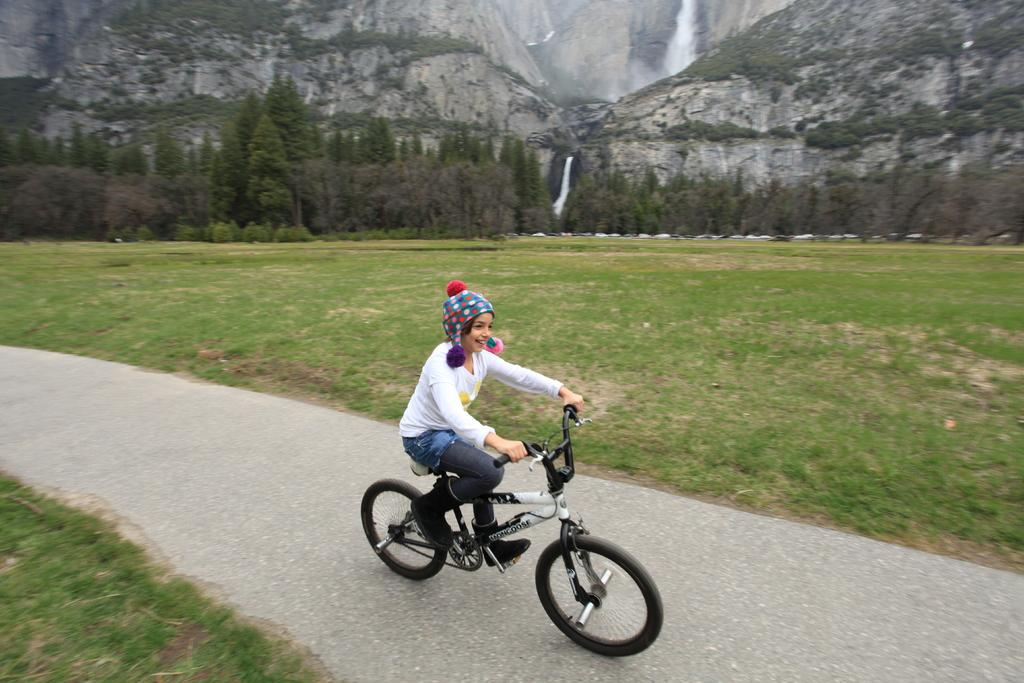Who is the main subject in the image? There is a girl in the image. What is the girl doing in the image? The girl is riding a bicycle. How does the girl appear to be feeling in the image? The girl has a smile on her face, suggesting she is happy. What type of terrain is visible in the image? There is grass on the ground. What can be seen in the distance in the image? There are mountains and trees in the background of the image. What type of flowers can be seen in the girl's pocket in the image? There is no mention of flowers or a pocket in the image, so we cannot answer this question. 